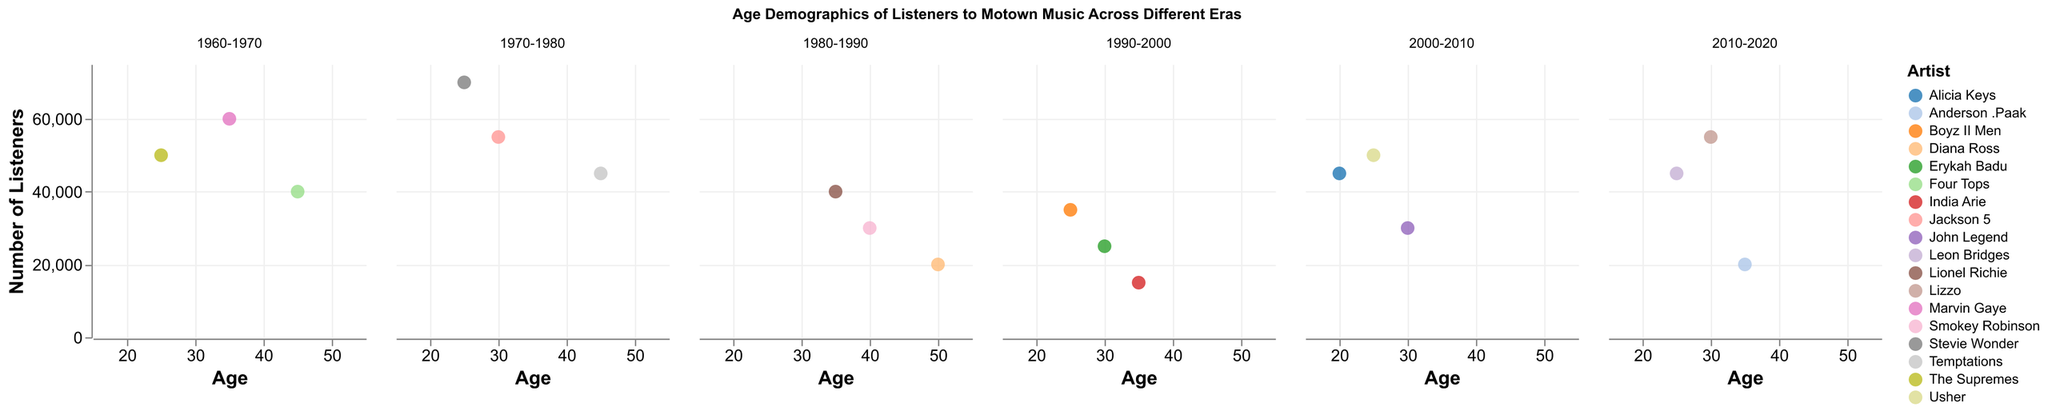What era has the highest number of listeners? By examining the y-axes across all subplots, the era with the artist having the highest number of listeners is 1970-1980 with Stevie Wonder's 70,000 listeners.
Answer: 1970-1980 Which artist is popular among the youngest listeners? The X-axis represents the age of listeners, and the youngest age is 20, associated with Alicia Keys from the 2000-2010 era.
Answer: Alicia Keys In the 1960-1970 era, which artist has the most listeners? By assessing the y-axis in the 1960-1970 subplot, Marvin Gaye has the highest number of listeners at 60,000.
Answer: Marvin Gaye How does the number of listeners for Lizzo compare to Leon Bridges? In the 2010-2020 subplot, Lizzo has 55,000 listeners while Leon Bridges has 45,000. Lizzo has 10,000 more listeners than Leon Bridges.
Answer: Lizzo has 10,000 more listeners What is the average age of listeners for the 1990-2000 era? The ages of listeners for the 1990-2000 era are 25, 30, and 35. The average is calculated by (25 + 30 + 35) / 3 = 90 / 3 = 30.
Answer: 30 Which artist from the 1980-1990 era has the least amount of listeners, and how many do they have? By checking the y-axis values in the 1980-1990 subplot, India Arie has the least number of listeners at 15,000.
Answer: India Arie, 15,000 What is the difference in listeners between the most and least popular artists in the 2000-2010 era? In the 2000-2010 subplot, Usher has the most listeners at 50,000, and John Legend has the least at 30,000. The difference is 50,000 - 30,000 = 20,000.
Answer: 20,000 Which eras have multiple artists whose listeners' ages are 35? By examining the subplots, the 1960-1970 era (Marvin Gaye) and the 2010-2020 era (Anderson .Paak) both have artists with listeners at age 35.
Answer: 1960-1970, 2010-2020 Who has more listeners: The Supremes or the Temptations? The Supremes have 50,000 listeners, and the Temptations have 45,000 listeners. The Supremes have more listeners.
Answer: The Supremes What is the total number of listeners for artists from the 2000-2010 era? Adding the listeners for the 2000-2010 era: Alicia Keys (45,000), Usher (50,000), and John Legend (30,000) results in 45,000 + 50,000 + 30,000 = 125,000.
Answer: 125,000 